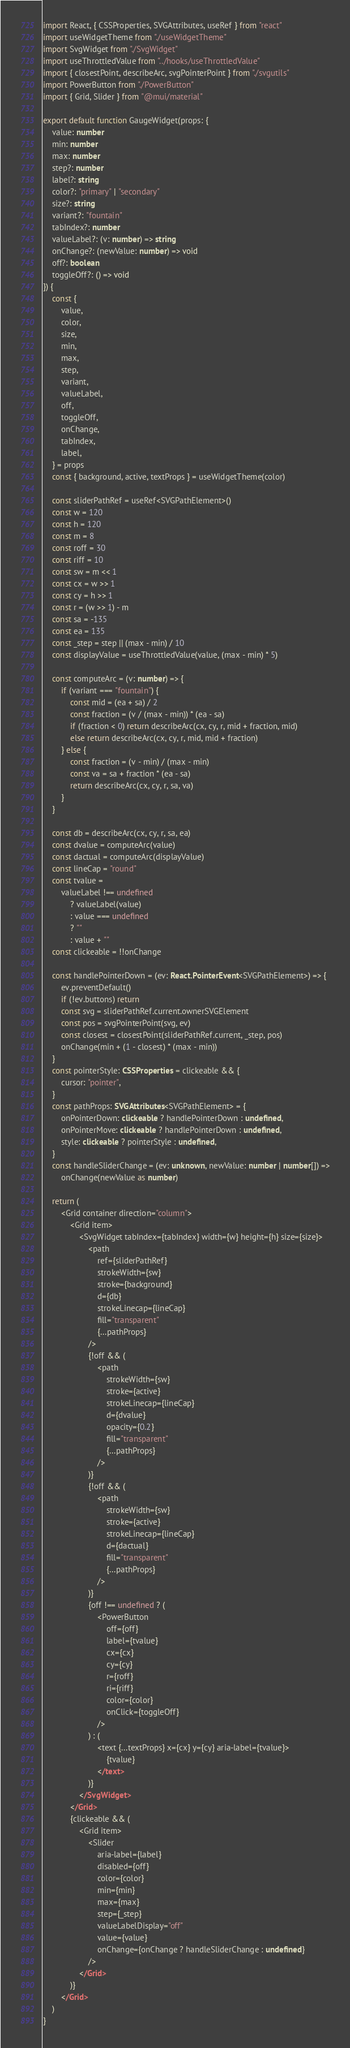<code> <loc_0><loc_0><loc_500><loc_500><_TypeScript_>import React, { CSSProperties, SVGAttributes, useRef } from "react"
import useWidgetTheme from "./useWidgetTheme"
import SvgWidget from "./SvgWidget"
import useThrottledValue from "../hooks/useThrottledValue"
import { closestPoint, describeArc, svgPointerPoint } from "./svgutils"
import PowerButton from "./PowerButton"
import { Grid, Slider } from "@mui/material"

export default function GaugeWidget(props: {
    value: number
    min: number
    max: number
    step?: number
    label?: string
    color?: "primary" | "secondary"
    size?: string
    variant?: "fountain"
    tabIndex?: number
    valueLabel?: (v: number) => string
    onChange?: (newValue: number) => void
    off?: boolean
    toggleOff?: () => void
}) {
    const {
        value,
        color,
        size,
        min,
        max,
        step,
        variant,
        valueLabel,
        off,
        toggleOff,
        onChange,
        tabIndex,
        label,
    } = props
    const { background, active, textProps } = useWidgetTheme(color)

    const sliderPathRef = useRef<SVGPathElement>()
    const w = 120
    const h = 120
    const m = 8
    const roff = 30
    const riff = 10
    const sw = m << 1
    const cx = w >> 1
    const cy = h >> 1
    const r = (w >> 1) - m
    const sa = -135
    const ea = 135
    const _step = step || (max - min) / 10
    const displayValue = useThrottledValue(value, (max - min) * 5)

    const computeArc = (v: number) => {
        if (variant === "fountain") {
            const mid = (ea + sa) / 2
            const fraction = (v / (max - min)) * (ea - sa)
            if (fraction < 0) return describeArc(cx, cy, r, mid + fraction, mid)
            else return describeArc(cx, cy, r, mid, mid + fraction)
        } else {
            const fraction = (v - min) / (max - min)
            const va = sa + fraction * (ea - sa)
            return describeArc(cx, cy, r, sa, va)
        }
    }

    const db = describeArc(cx, cy, r, sa, ea)
    const dvalue = computeArc(value)
    const dactual = computeArc(displayValue)
    const lineCap = "round"
    const tvalue =
        valueLabel !== undefined
            ? valueLabel(value)
            : value === undefined
            ? ""
            : value + ""
    const clickeable = !!onChange

    const handlePointerDown = (ev: React.PointerEvent<SVGPathElement>) => {
        ev.preventDefault()
        if (!ev.buttons) return
        const svg = sliderPathRef.current.ownerSVGElement
        const pos = svgPointerPoint(svg, ev)
        const closest = closestPoint(sliderPathRef.current, _step, pos)
        onChange(min + (1 - closest) * (max - min))
    }
    const pointerStyle: CSSProperties = clickeable && {
        cursor: "pointer",
    }
    const pathProps: SVGAttributes<SVGPathElement> = {
        onPointerDown: clickeable ? handlePointerDown : undefined,
        onPointerMove: clickeable ? handlePointerDown : undefined,
        style: clickeable ? pointerStyle : undefined,
    }
    const handleSliderChange = (ev: unknown, newValue: number | number[]) =>
        onChange(newValue as number)

    return (
        <Grid container direction="column">
            <Grid item>
                <SvgWidget tabIndex={tabIndex} width={w} height={h} size={size}>
                    <path
                        ref={sliderPathRef}
                        strokeWidth={sw}
                        stroke={background}
                        d={db}
                        strokeLinecap={lineCap}
                        fill="transparent"
                        {...pathProps}
                    />
                    {!off && (
                        <path
                            strokeWidth={sw}
                            stroke={active}
                            strokeLinecap={lineCap}
                            d={dvalue}
                            opacity={0.2}
                            fill="transparent"
                            {...pathProps}
                        />
                    )}
                    {!off && (
                        <path
                            strokeWidth={sw}
                            stroke={active}
                            strokeLinecap={lineCap}
                            d={dactual}
                            fill="transparent"
                            {...pathProps}
                        />
                    )}
                    {off !== undefined ? (
                        <PowerButton
                            off={off}
                            label={tvalue}
                            cx={cx}
                            cy={cy}
                            r={roff}
                            ri={riff}
                            color={color}
                            onClick={toggleOff}
                        />
                    ) : (
                        <text {...textProps} x={cx} y={cy} aria-label={tvalue}>
                            {tvalue}
                        </text>
                    )}
                </SvgWidget>
            </Grid>
            {clickeable && (
                <Grid item>
                    <Slider
                        aria-label={label}
                        disabled={off}
                        color={color}
                        min={min}
                        max={max}
                        step={_step}
                        valueLabelDisplay="off"
                        value={value}
                        onChange={onChange ? handleSliderChange : undefined}
                    />
                </Grid>
            )}
        </Grid>
    )
}
</code> 